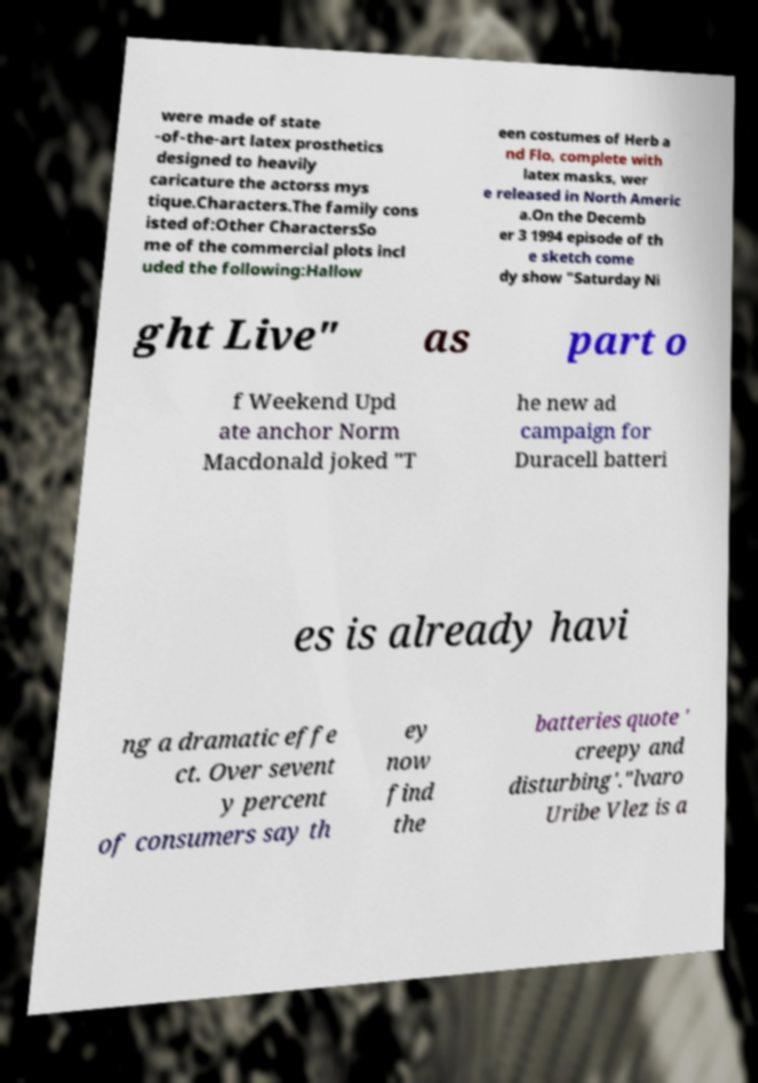There's text embedded in this image that I need extracted. Can you transcribe it verbatim? were made of state -of-the-art latex prosthetics designed to heavily caricature the actorss mys tique.Characters.The family cons isted of:Other CharactersSo me of the commercial plots incl uded the following:Hallow een costumes of Herb a nd Flo, complete with latex masks, wer e released in North Americ a.On the Decemb er 3 1994 episode of th e sketch come dy show "Saturday Ni ght Live" as part o f Weekend Upd ate anchor Norm Macdonald joked "T he new ad campaign for Duracell batteri es is already havi ng a dramatic effe ct. Over sevent y percent of consumers say th ey now find the batteries quote ' creepy and disturbing'."lvaro Uribe Vlez is a 